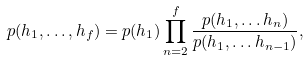<formula> <loc_0><loc_0><loc_500><loc_500>p ( h _ { 1 } , \dots , h _ { f } ) = p ( h _ { 1 } ) \prod _ { n = 2 } ^ { f } \frac { p ( h _ { 1 } , \dots h _ { n } ) } { p ( h _ { 1 } , \dots h _ { n - 1 } ) } ,</formula> 